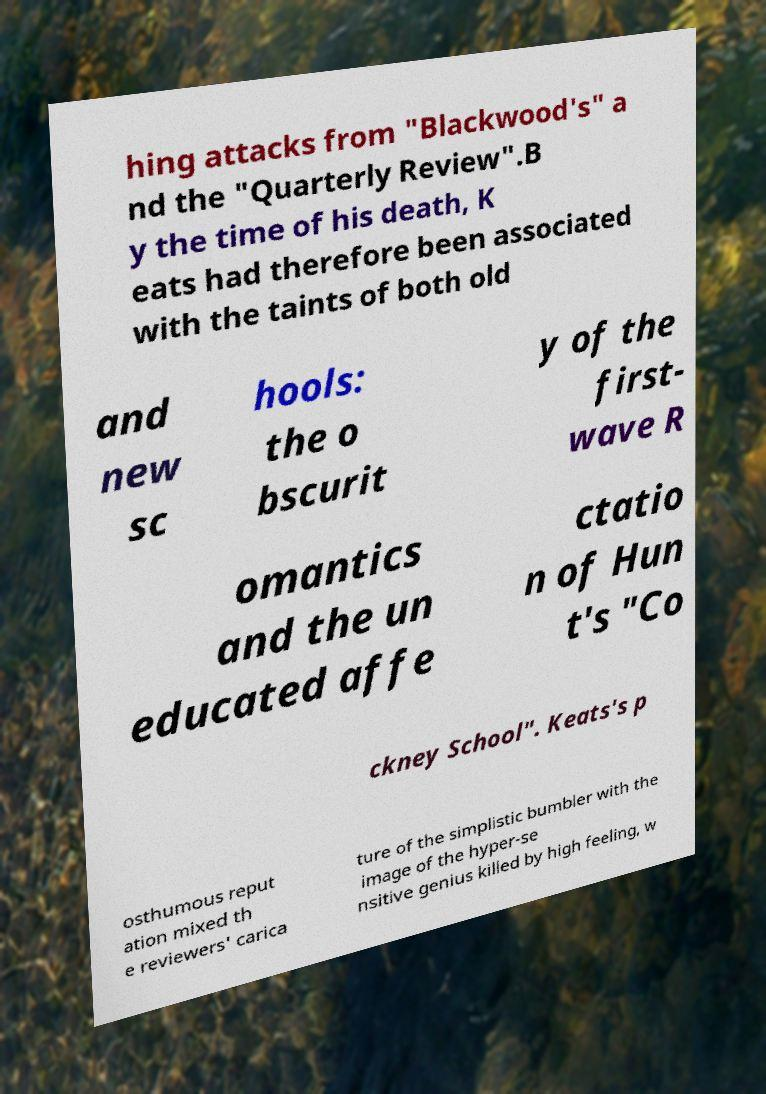What messages or text are displayed in this image? I need them in a readable, typed format. hing attacks from "Blackwood's" a nd the "Quarterly Review".B y the time of his death, K eats had therefore been associated with the taints of both old and new sc hools: the o bscurit y of the first- wave R omantics and the un educated affe ctatio n of Hun t's "Co ckney School". Keats's p osthumous reput ation mixed th e reviewers' carica ture of the simplistic bumbler with the image of the hyper-se nsitive genius killed by high feeling, w 